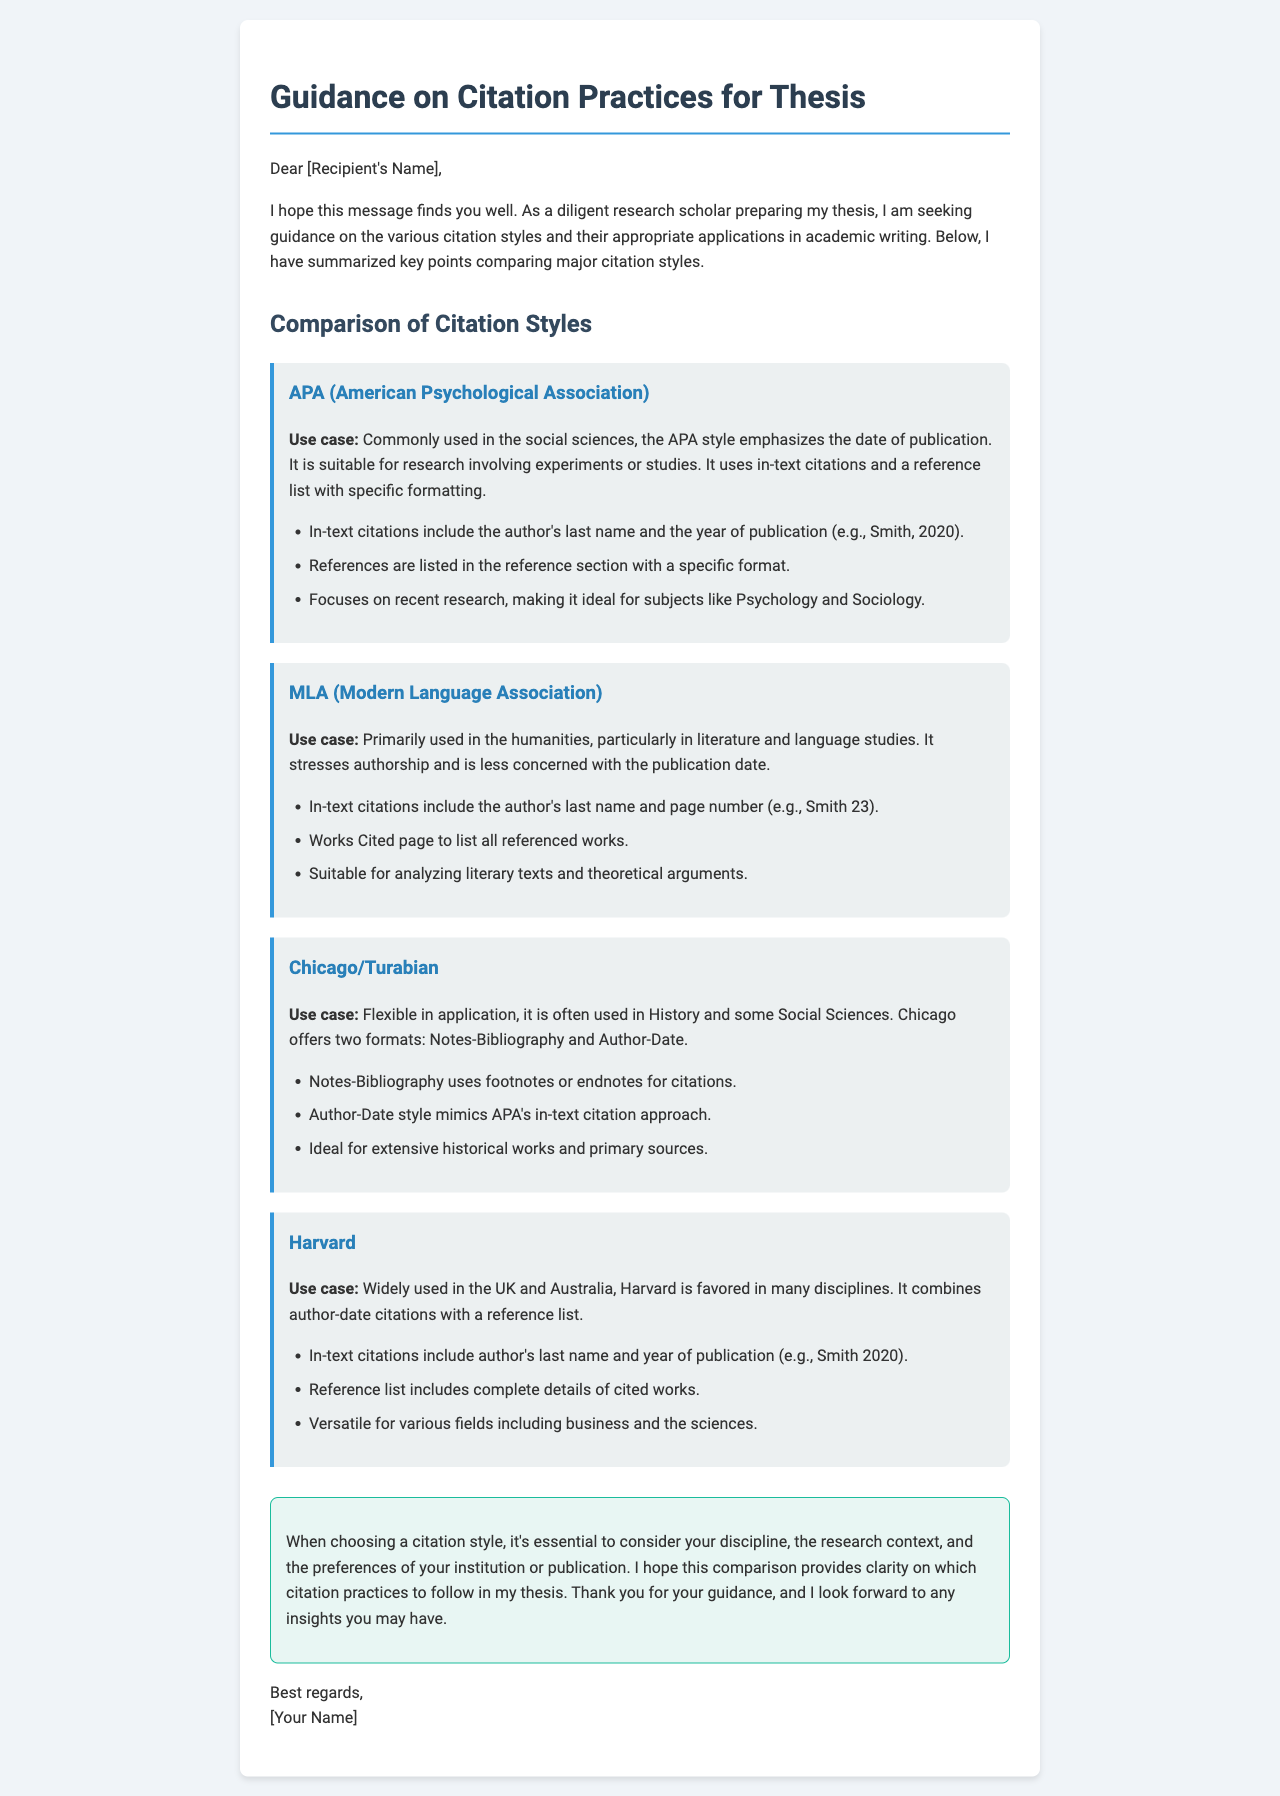What citation style is commonly used in the social sciences? The document states that APA is commonly used in the social sciences.
Answer: APA Which citation style emphasizes authorship over publication date? According to the document, MLA primarily emphasizes authorship.
Answer: MLA What is the suitable field for Chicago citation style? The document mentions that Chicago is often used in History and some Social Sciences.
Answer: History In-text citations for Harvard include what two elements? The document explains that Harvard in-text citations include the author's last name and year of publication.
Answer: author's last name and year Which citation style uses footnotes or endnotes for citations? The document states that Chicago/Turabian's Notes-Bibliography uses footnotes or endnotes.
Answer: Chicago/Turabian What is the focus of APA citation style? The document indicates that APA focuses on recent research.
Answer: recent research What is a common application of MLA citation style? The document describes that MLA is suitable for analyzing literary texts and theoretical arguments.
Answer: literary texts What is the country where Harvard citation style is widely used? The document mentions that Harvard is widely used in the UK and Australia.
Answer: UK and Australia 